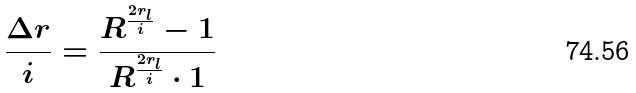Convert formula to latex. <formula><loc_0><loc_0><loc_500><loc_500>\frac { \Delta r } { i } = \frac { R ^ { \frac { 2 r _ { l } } { i } } - 1 } { R ^ { \frac { 2 r _ { l } } { i } } \cdot 1 }</formula> 